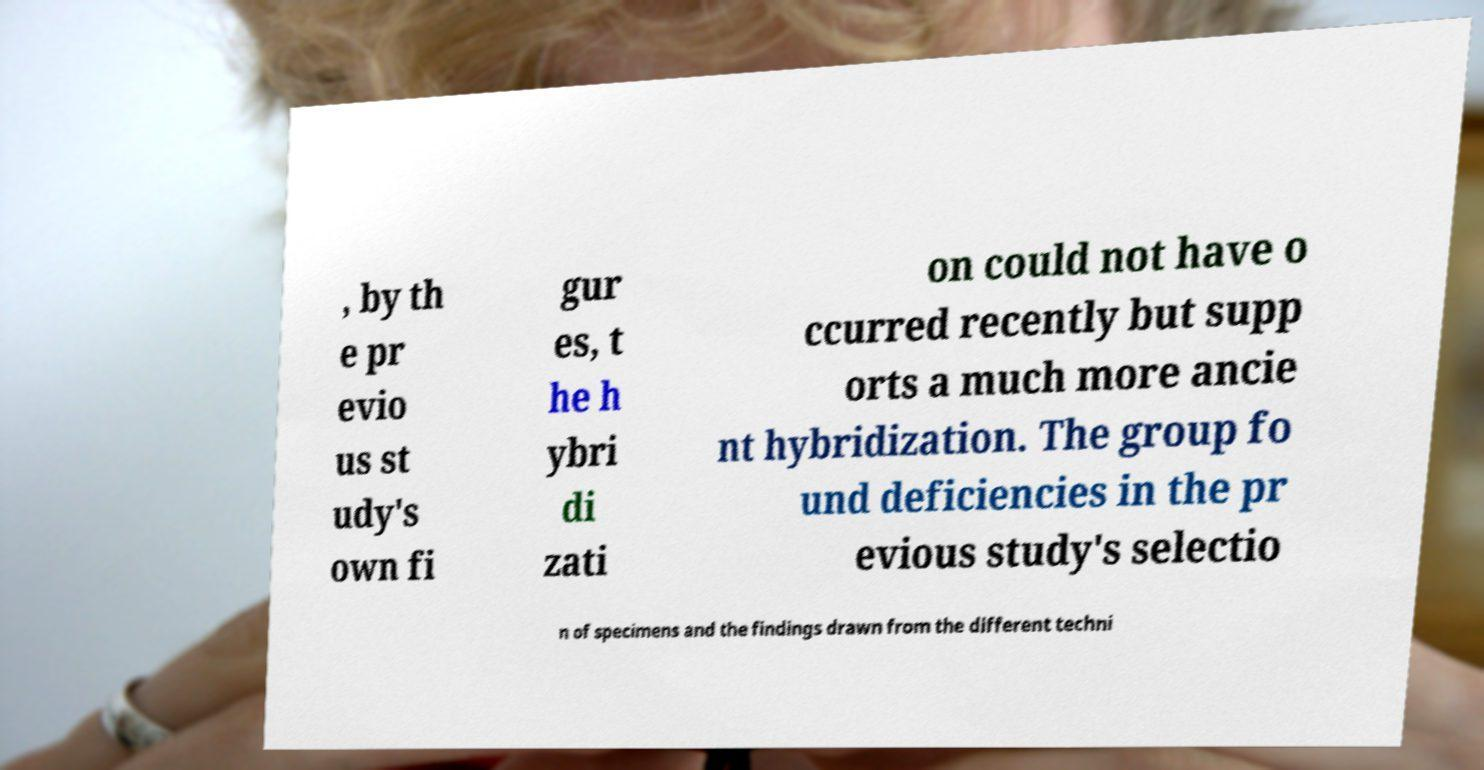Please identify and transcribe the text found in this image. , by th e pr evio us st udy's own fi gur es, t he h ybri di zati on could not have o ccurred recently but supp orts a much more ancie nt hybridization. The group fo und deficiencies in the pr evious study's selectio n of specimens and the findings drawn from the different techni 